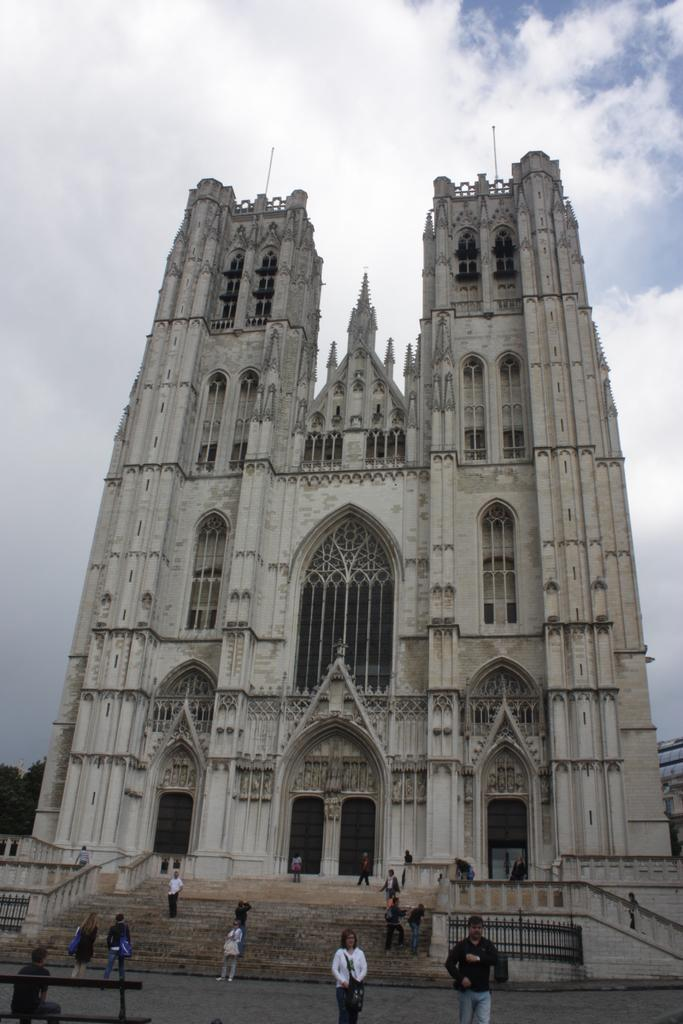What is the main structure in the image? There is a building in the middle of the image. What is located in front of the building? There are steps in front of the building. Are there any people near the building? Yes, there are people on the steps. What is visible at the top of the image? The sky is visible at the top of the image. What type of vegetable is being used as a decoration on the building in the image? There is no vegetable being used as a decoration on the building in the image. 